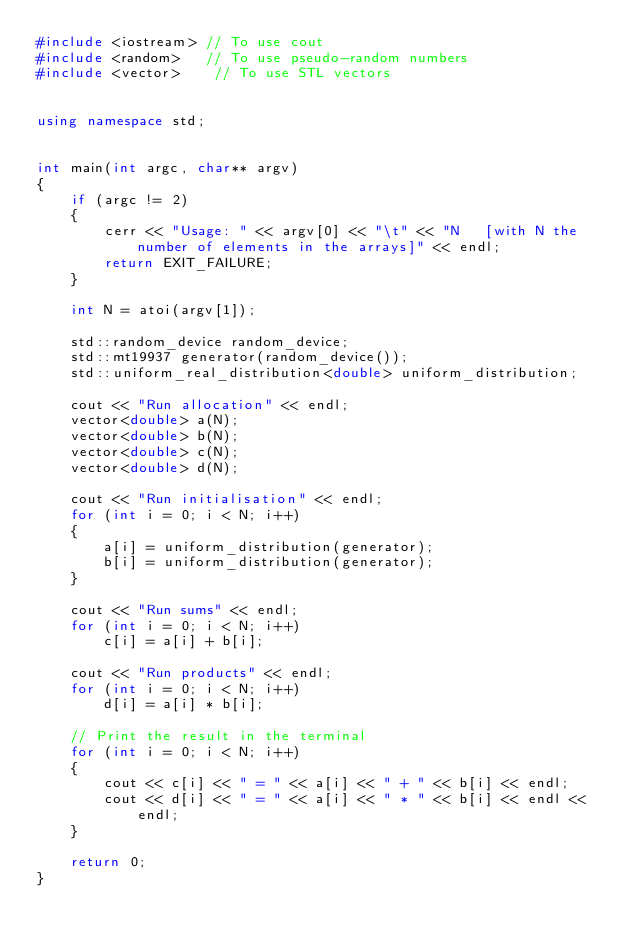<code> <loc_0><loc_0><loc_500><loc_500><_C++_>#include <iostream> // To use cout
#include <random>   // To use pseudo-random numbers
#include <vector>    // To use STL vectors


using namespace std;


int main(int argc, char** argv)
{
    if (argc != 2)
    {
        cerr << "Usage: " << argv[0] << "\t" << "N   [with N the number of elements in the arrays]" << endl;
        return EXIT_FAILURE;
    }

    int N = atoi(argv[1]);

    std::random_device random_device;
    std::mt19937 generator(random_device());
    std::uniform_real_distribution<double> uniform_distribution;

    cout << "Run allocation" << endl;
    vector<double> a(N);
    vector<double> b(N);
    vector<double> c(N);
    vector<double> d(N);

    cout << "Run initialisation" << endl;
    for (int i = 0; i < N; i++)
    {
        a[i] = uniform_distribution(generator);
        b[i] = uniform_distribution(generator);
    }

    cout << "Run sums" << endl;
    for (int i = 0; i < N; i++)
        c[i] = a[i] + b[i];

    cout << "Run products" << endl;
    for (int i = 0; i < N; i++)
        d[i] = a[i] * b[i];

    // Print the result in the terminal
    for (int i = 0; i < N; i++)
    {
        cout << c[i] << " = " << a[i] << " + " << b[i] << endl;
        cout << d[i] << " = " << a[i] << " * " << b[i] << endl << endl;
    }

    return 0;
}
</code> 